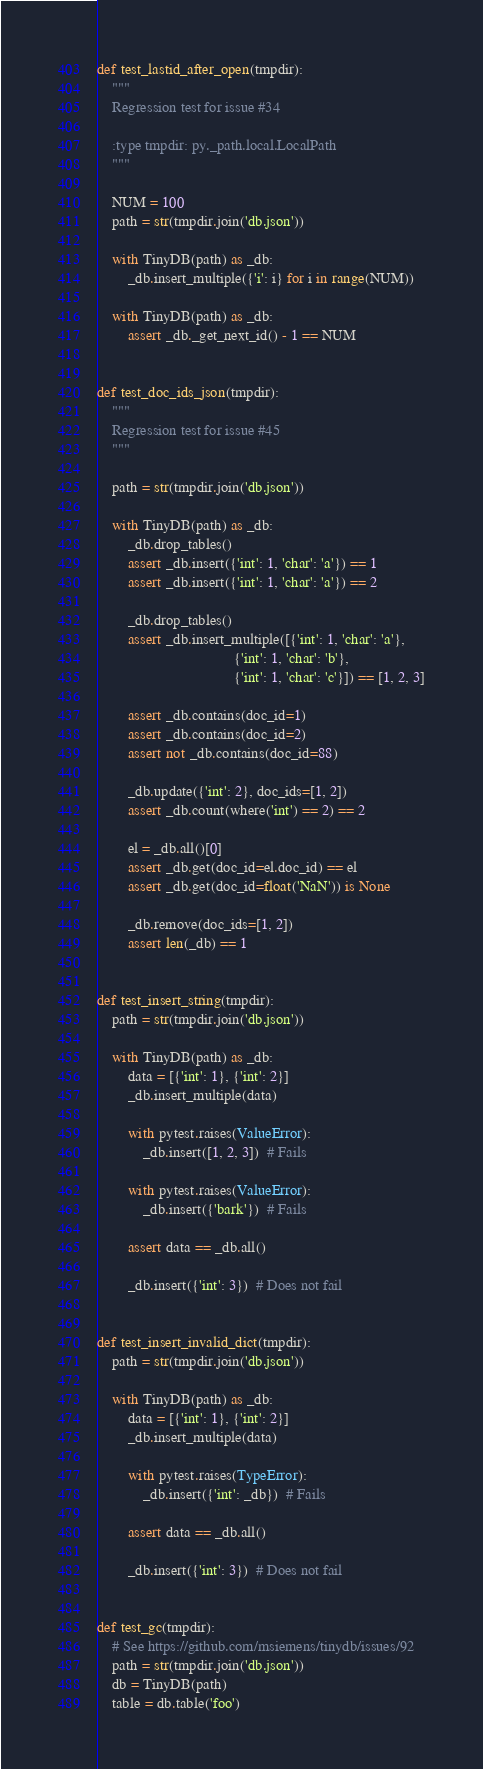<code> <loc_0><loc_0><loc_500><loc_500><_Python_>def test_lastid_after_open(tmpdir):
    """
    Regression test for issue #34

    :type tmpdir: py._path.local.LocalPath
    """

    NUM = 100
    path = str(tmpdir.join('db.json'))

    with TinyDB(path) as _db:
        _db.insert_multiple({'i': i} for i in range(NUM))

    with TinyDB(path) as _db:
        assert _db._get_next_id() - 1 == NUM


def test_doc_ids_json(tmpdir):
    """
    Regression test for issue #45
    """

    path = str(tmpdir.join('db.json'))

    with TinyDB(path) as _db:
        _db.drop_tables()
        assert _db.insert({'int': 1, 'char': 'a'}) == 1
        assert _db.insert({'int': 1, 'char': 'a'}) == 2

        _db.drop_tables()
        assert _db.insert_multiple([{'int': 1, 'char': 'a'},
                                    {'int': 1, 'char': 'b'},
                                    {'int': 1, 'char': 'c'}]) == [1, 2, 3]

        assert _db.contains(doc_id=1)
        assert _db.contains(doc_id=2)
        assert not _db.contains(doc_id=88)

        _db.update({'int': 2}, doc_ids=[1, 2])
        assert _db.count(where('int') == 2) == 2

        el = _db.all()[0]
        assert _db.get(doc_id=el.doc_id) == el
        assert _db.get(doc_id=float('NaN')) is None

        _db.remove(doc_ids=[1, 2])
        assert len(_db) == 1


def test_insert_string(tmpdir):
    path = str(tmpdir.join('db.json'))

    with TinyDB(path) as _db:
        data = [{'int': 1}, {'int': 2}]
        _db.insert_multiple(data)

        with pytest.raises(ValueError):
            _db.insert([1, 2, 3])  # Fails

        with pytest.raises(ValueError):
            _db.insert({'bark'})  # Fails

        assert data == _db.all()

        _db.insert({'int': 3})  # Does not fail


def test_insert_invalid_dict(tmpdir):
    path = str(tmpdir.join('db.json'))

    with TinyDB(path) as _db:
        data = [{'int': 1}, {'int': 2}]
        _db.insert_multiple(data)

        with pytest.raises(TypeError):
            _db.insert({'int': _db})  # Fails

        assert data == _db.all()

        _db.insert({'int': 3})  # Does not fail


def test_gc(tmpdir):
    # See https://github.com/msiemens/tinydb/issues/92
    path = str(tmpdir.join('db.json'))
    db = TinyDB(path)
    table = db.table('foo')</code> 